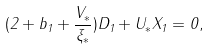Convert formula to latex. <formula><loc_0><loc_0><loc_500><loc_500>( 2 + b _ { 1 } + \frac { V _ { \ast } } { \xi _ { \ast } } ) D _ { 1 } + U _ { \ast } X _ { 1 } = 0 ,</formula> 